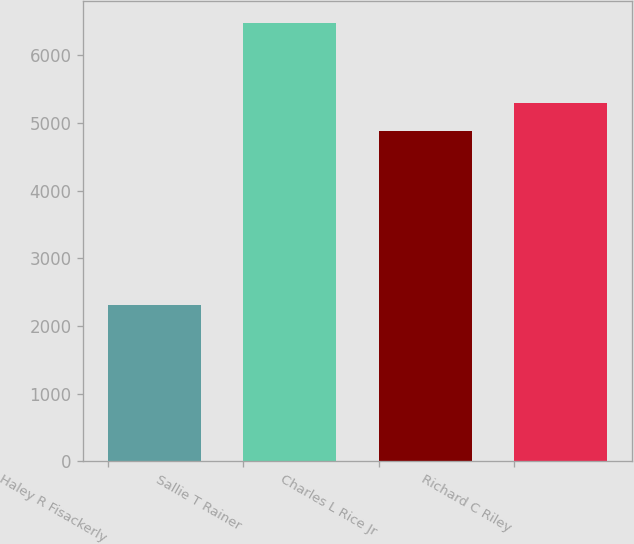Convert chart to OTSL. <chart><loc_0><loc_0><loc_500><loc_500><bar_chart><fcel>Haley R Fisackerly<fcel>Sallie T Rainer<fcel>Charles L Rice Jr<fcel>Richard C Riley<nl><fcel>2306<fcel>6477<fcel>4874<fcel>5291.1<nl></chart> 